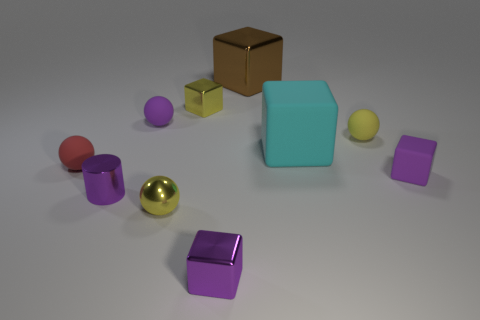Subtract all yellow blocks. How many blocks are left? 4 Subtract 2 blocks. How many blocks are left? 3 Subtract all matte cubes. How many cubes are left? 3 Subtract all green balls. Subtract all brown blocks. How many balls are left? 4 Subtract all cylinders. How many objects are left? 9 Add 7 large rubber blocks. How many large rubber blocks exist? 8 Subtract 0 red cylinders. How many objects are left? 10 Subtract all large cyan blocks. Subtract all small red matte objects. How many objects are left? 8 Add 2 tiny purple rubber things. How many tiny purple rubber things are left? 4 